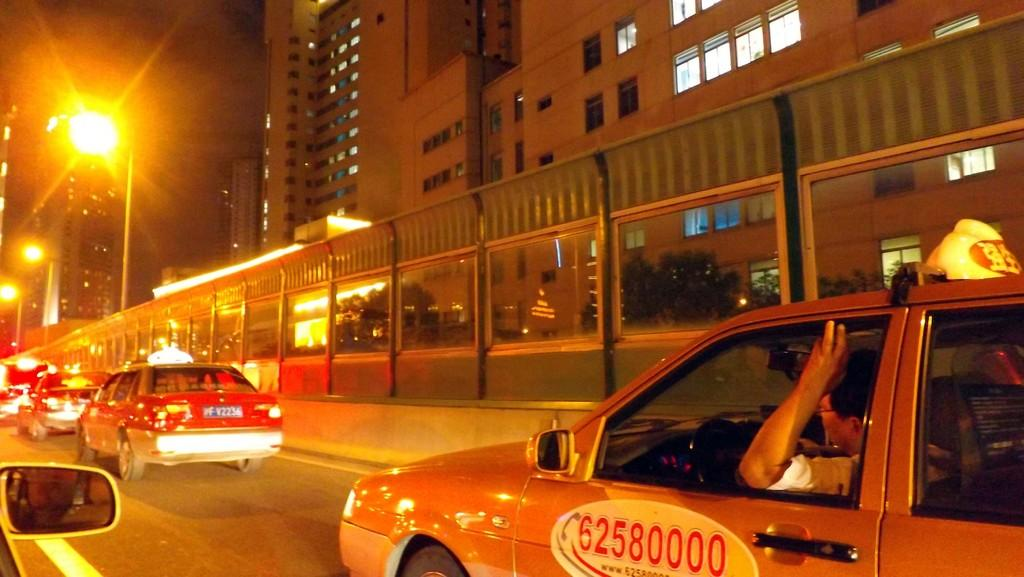<image>
Share a concise interpretation of the image provided. a taxi with phone number 62580000 lit up by a street lamp 